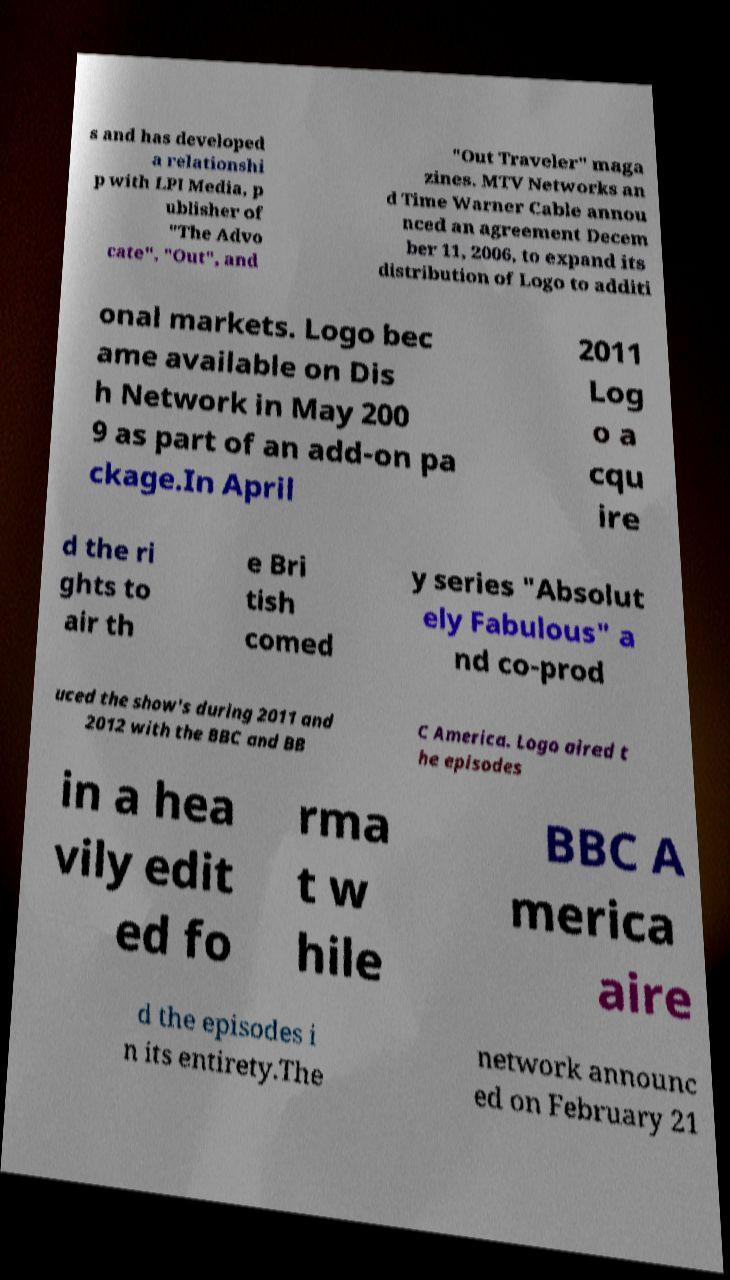Could you extract and type out the text from this image? s and has developed a relationshi p with LPI Media, p ublisher of "The Advo cate", "Out", and "Out Traveler" maga zines. MTV Networks an d Time Warner Cable annou nced an agreement Decem ber 11, 2006, to expand its distribution of Logo to additi onal markets. Logo bec ame available on Dis h Network in May 200 9 as part of an add-on pa ckage.In April 2011 Log o a cqu ire d the ri ghts to air th e Bri tish comed y series "Absolut ely Fabulous" a nd co-prod uced the show's during 2011 and 2012 with the BBC and BB C America. Logo aired t he episodes in a hea vily edit ed fo rma t w hile BBC A merica aire d the episodes i n its entirety.The network announc ed on February 21 